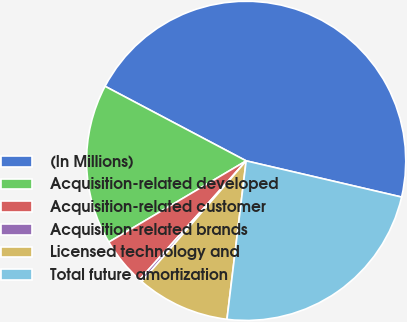<chart> <loc_0><loc_0><loc_500><loc_500><pie_chart><fcel>(In Millions)<fcel>Acquisition-related developed<fcel>Acquisition-related customer<fcel>Acquisition-related brands<fcel>Licensed technology and<fcel>Total future amortization<nl><fcel>45.91%<fcel>16.24%<fcel>4.86%<fcel>0.3%<fcel>9.42%<fcel>23.28%<nl></chart> 